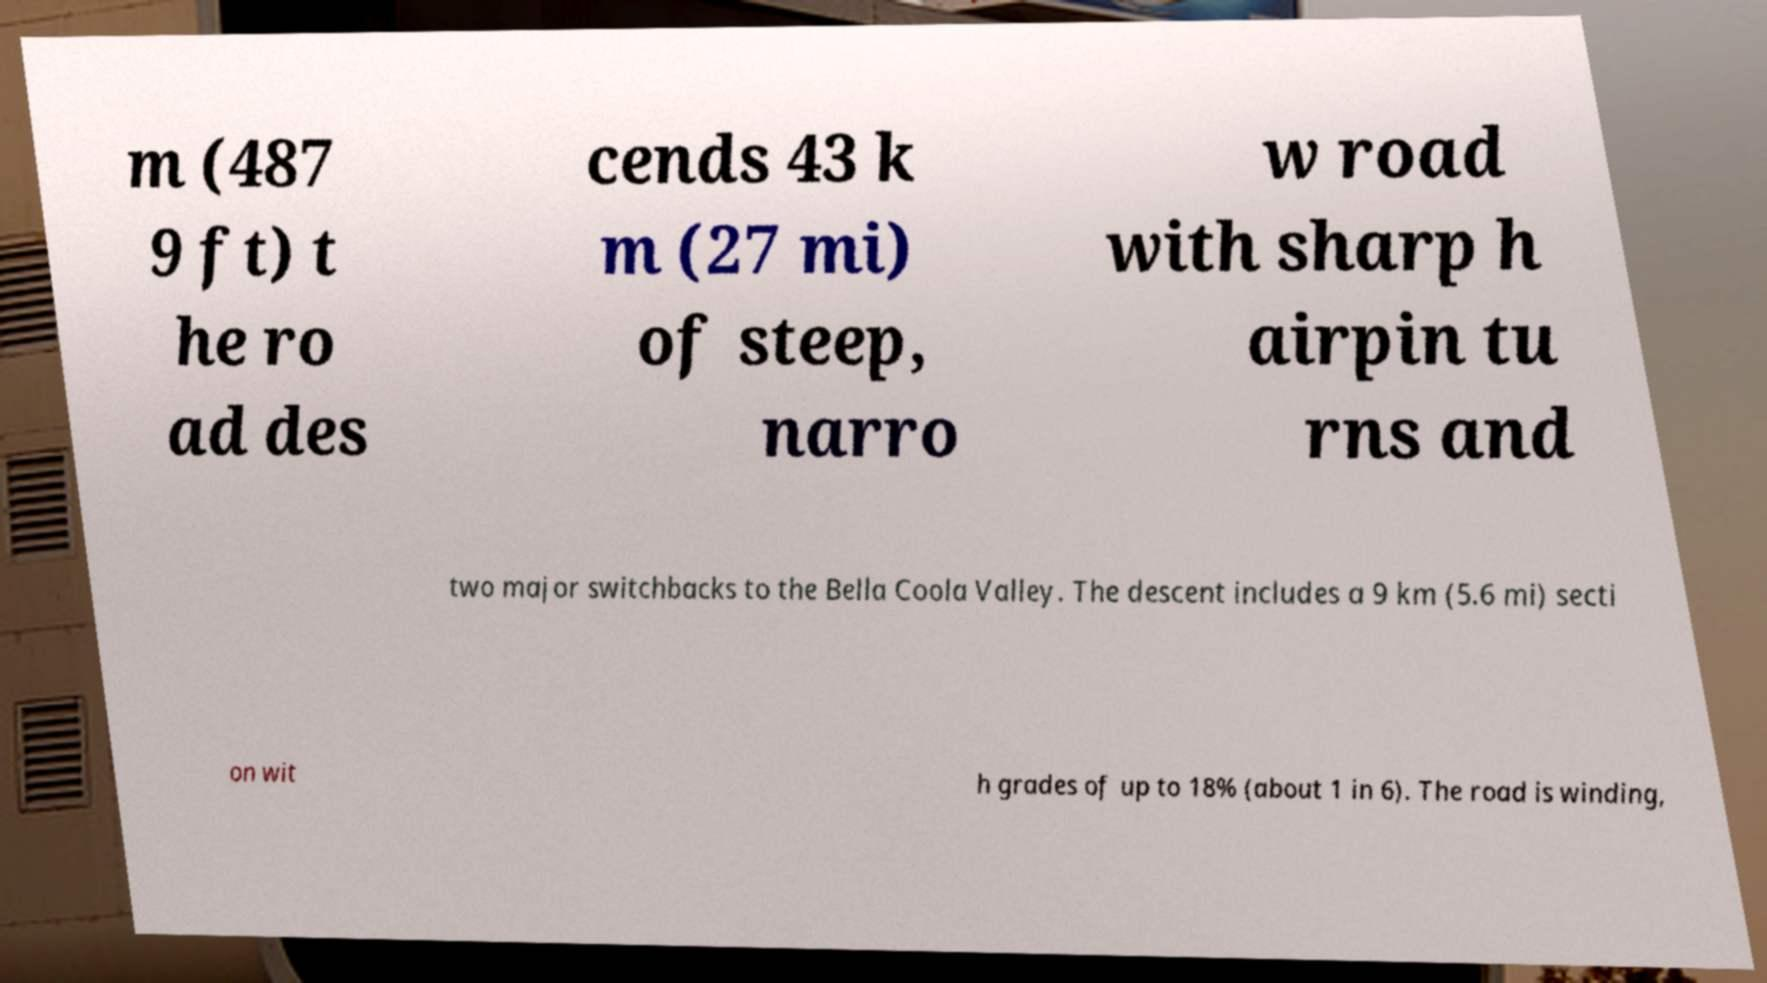Could you assist in decoding the text presented in this image and type it out clearly? m (487 9 ft) t he ro ad des cends 43 k m (27 mi) of steep, narro w road with sharp h airpin tu rns and two major switchbacks to the Bella Coola Valley. The descent includes a 9 km (5.6 mi) secti on wit h grades of up to 18% (about 1 in 6). The road is winding, 